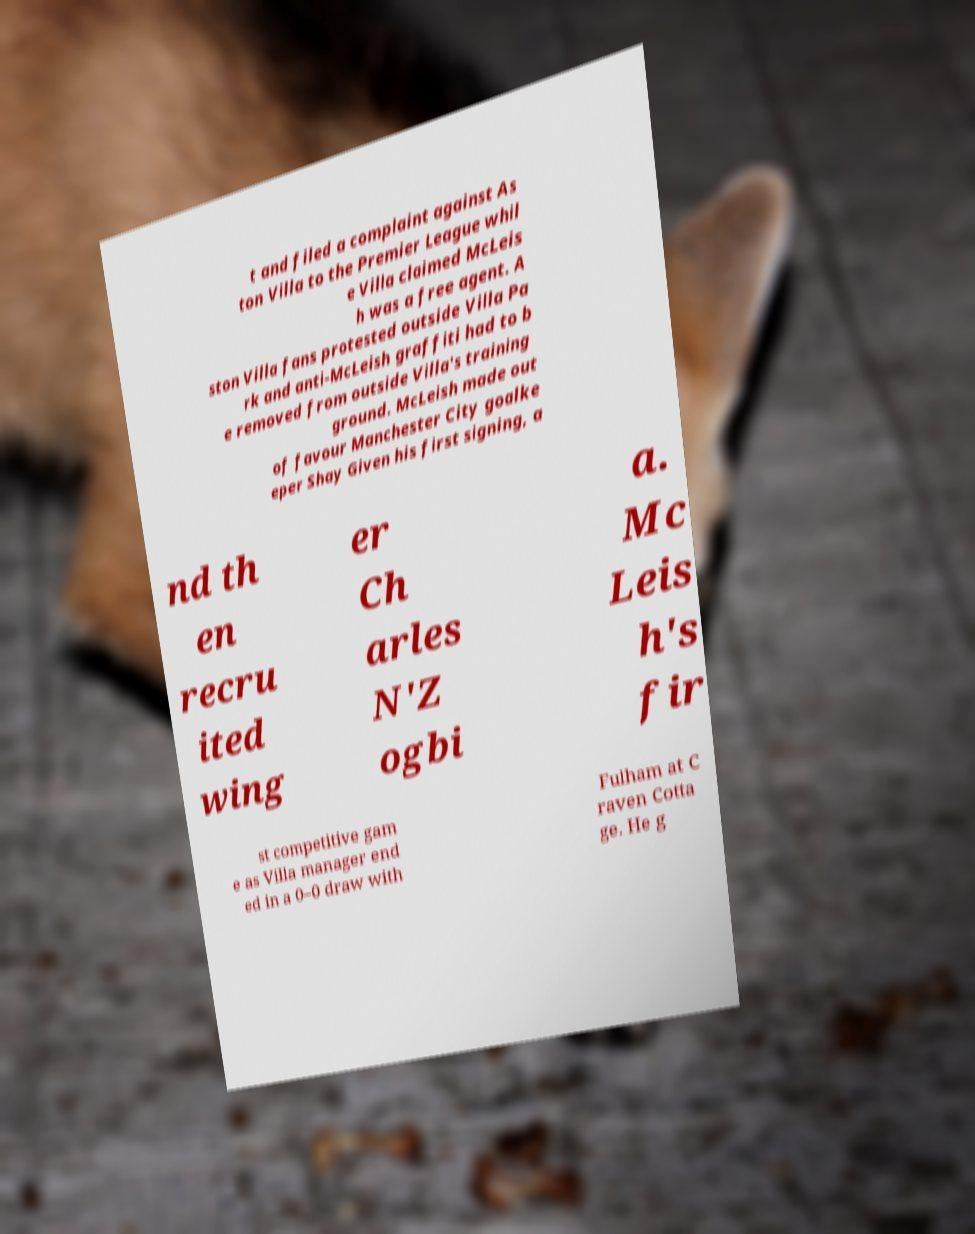Can you read and provide the text displayed in the image?This photo seems to have some interesting text. Can you extract and type it out for me? t and filed a complaint against As ton Villa to the Premier League whil e Villa claimed McLeis h was a free agent. A ston Villa fans protested outside Villa Pa rk and anti-McLeish graffiti had to b e removed from outside Villa's training ground. McLeish made out of favour Manchester City goalke eper Shay Given his first signing, a nd th en recru ited wing er Ch arles N'Z ogbi a. Mc Leis h's fir st competitive gam e as Villa manager end ed in a 0–0 draw with Fulham at C raven Cotta ge. He g 